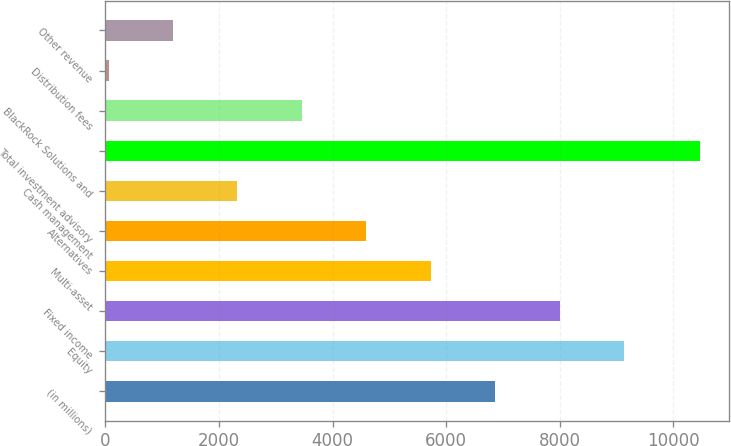<chart> <loc_0><loc_0><loc_500><loc_500><bar_chart><fcel>(in millions)<fcel>Equity<fcel>Fixed income<fcel>Multi-asset<fcel>Alternatives<fcel>Cash management<fcel>Total investment advisory<fcel>BlackRock Solutions and<fcel>Distribution fees<fcel>Other revenue<nl><fcel>6862.6<fcel>9131.8<fcel>7997.2<fcel>5728<fcel>4593.4<fcel>2324.2<fcel>10461<fcel>3458.8<fcel>55<fcel>1189.6<nl></chart> 